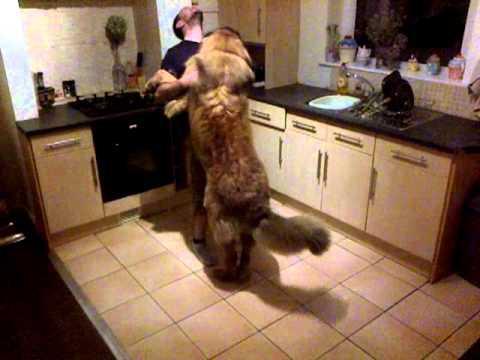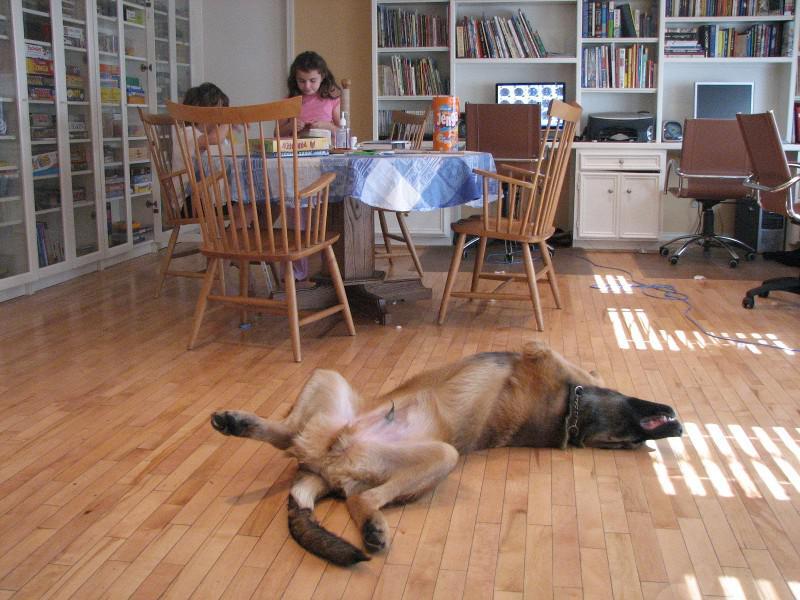The first image is the image on the left, the second image is the image on the right. Given the left and right images, does the statement "All the dogs are asleep." hold true? Answer yes or no. No. The first image is the image on the left, the second image is the image on the right. Assess this claim about the two images: "The dog in the left image is awake and alert.". Correct or not? Answer yes or no. Yes. 